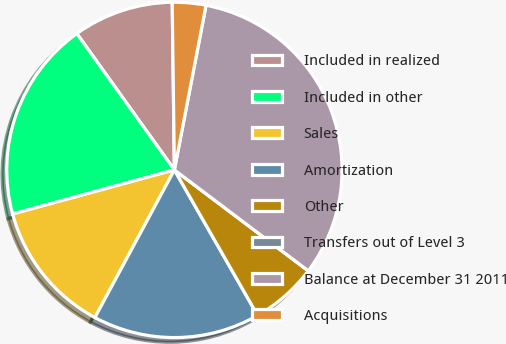Convert chart to OTSL. <chart><loc_0><loc_0><loc_500><loc_500><pie_chart><fcel>Included in realized<fcel>Included in other<fcel>Sales<fcel>Amortization<fcel>Other<fcel>Transfers out of Level 3<fcel>Balance at December 31 2011<fcel>Acquisitions<nl><fcel>9.68%<fcel>19.35%<fcel>12.9%<fcel>16.13%<fcel>6.45%<fcel>0.0%<fcel>32.25%<fcel>3.23%<nl></chart> 